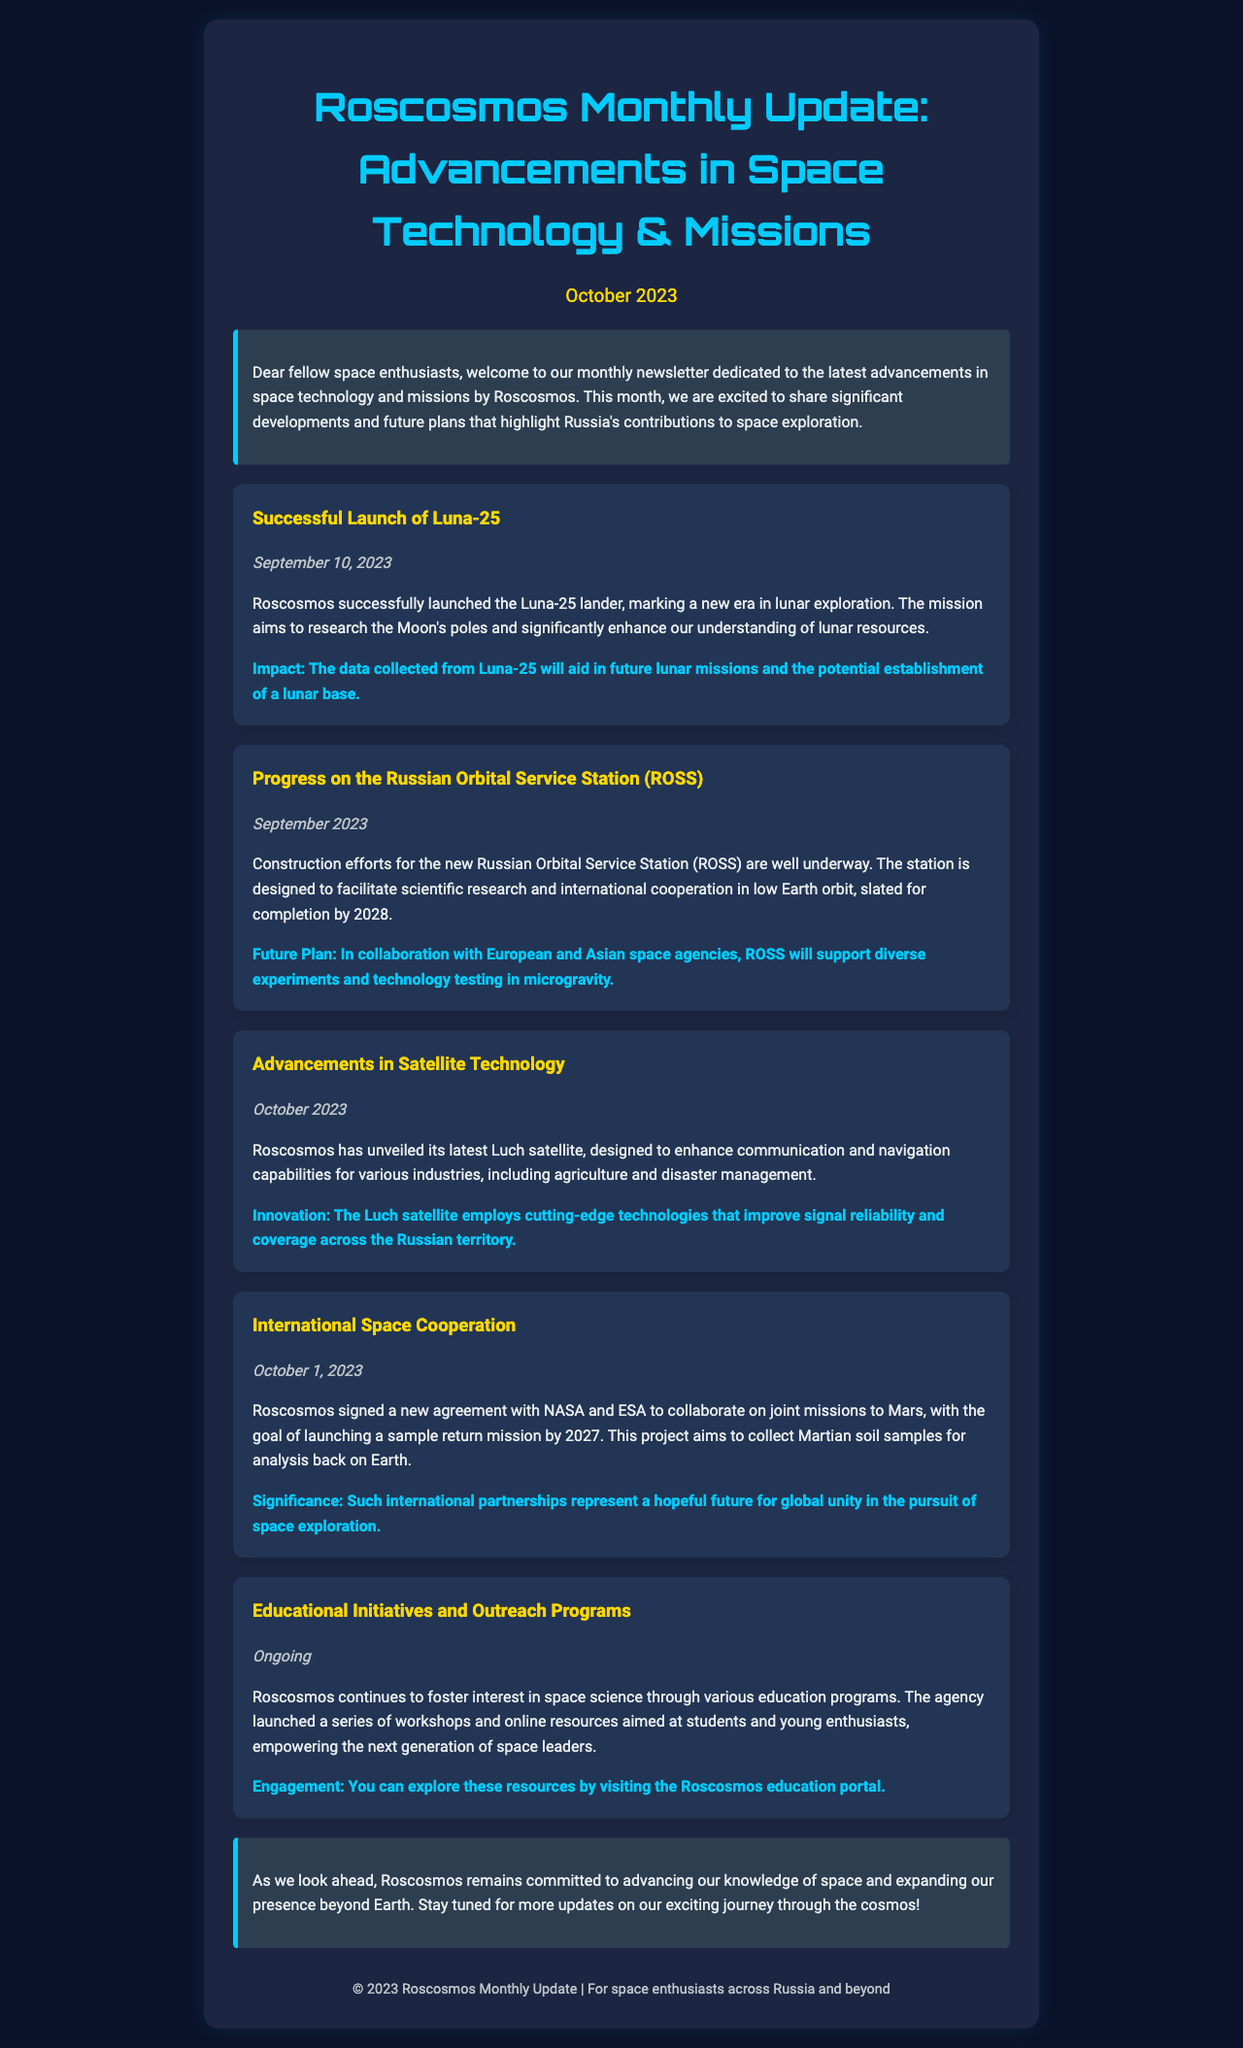What is the title of the newsletter? The title of the newsletter is provided in the header section of the document.
Answer: Roscosmos Monthly Update: Advancements in Space Technology & Missions When was the Luna-25 launched? The date of the Luna-25 launch is specifically mentioned in the update section about this mission.
Answer: September 10, 2023 What is the completion date set for the Russian Orbital Service Station (ROSS)? The document states the expected completion year for ROSS in its relevant update section.
Answer: 2028 What new satellite has Roscosmos unveiled? The document mentions the name of the newly unveiled satellite in the related update.
Answer: Luch satellite What is the primary goal of the Mars collaboration with NASA and ESA? The document outlines the main objective of the Mars mission cooperation in the relevant update.
Answer: Sample return mission What type of resources has Roscosmos launched for students and young enthusiasts? The newsletter describes the focus of Roscosmos' initiatives aimed at young people in the document.
Answer: Workshops and online resources What is the significance of the international collaboration on Mars missions? The meaning and importance of this collaboration are discussed in the relevant section of the newsletter.
Answer: Global unity in the pursuit of space exploration Which agency signed a collaboration agreement with Roscosmos? The document specifies the agencies that collaborated with Roscosmos in the Mars mission update.
Answer: NASA and ESA What does the data from Luna-25 help with? The update about Luna-25 describes its impact and contributions to future missions.
Answer: Future lunar missions and lunar base establishment 